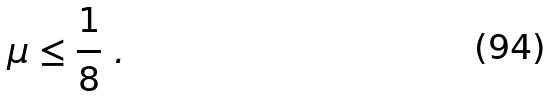<formula> <loc_0><loc_0><loc_500><loc_500>\mu \leq \frac { 1 } { 8 } \ .</formula> 